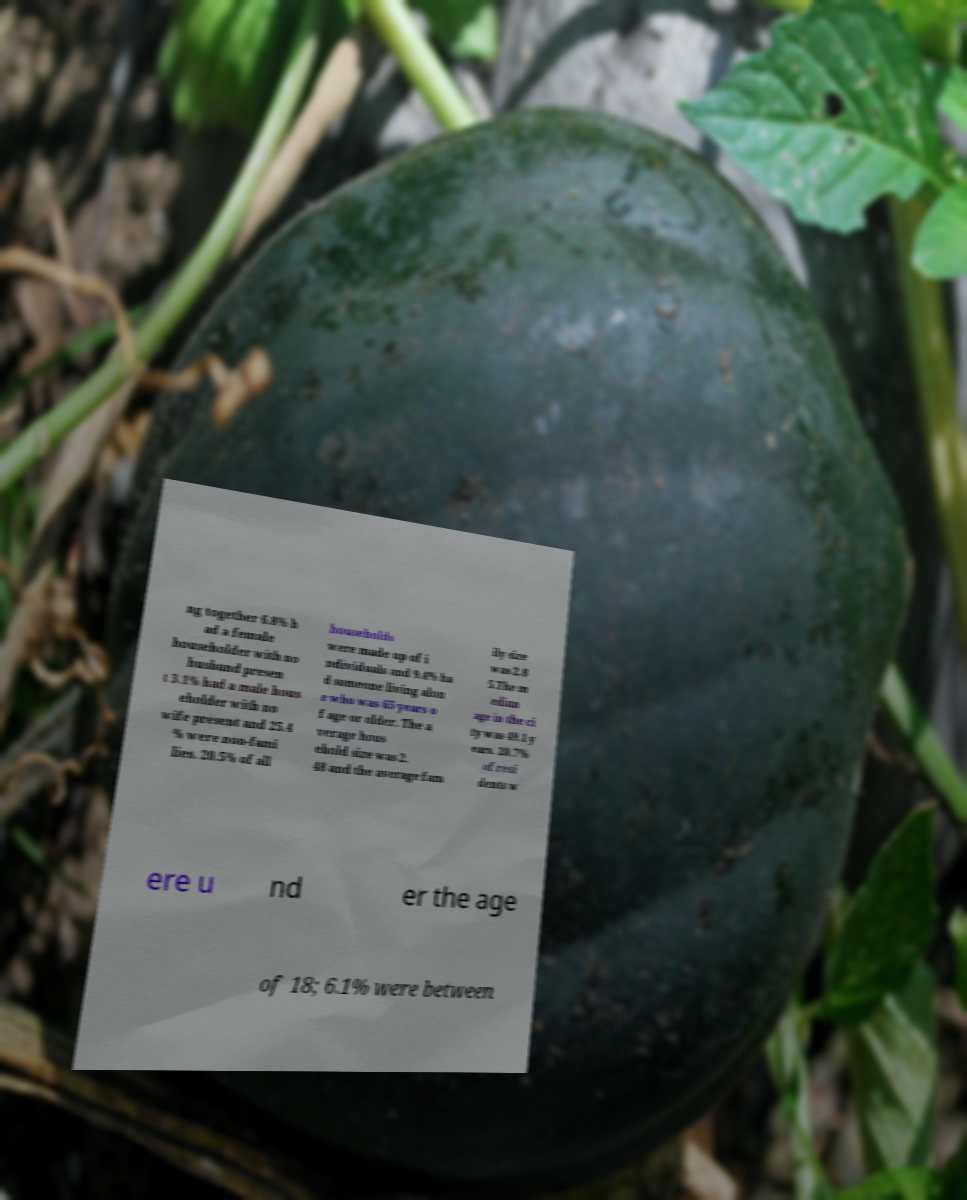For documentation purposes, I need the text within this image transcribed. Could you provide that? ng together 6.8% h ad a female householder with no husband presen t 3.1% had a male hous eholder with no wife present and 25.4 % were non-fami lies. 20.5% of all households were made up of i ndividuals and 9.4% ha d someone living alon e who was 65 years o f age or older. The a verage hous ehold size was 2. 48 and the average fam ily size was 2.8 5.The m edian age in the ci ty was 49.1 y ears. 20.7% of resi dents w ere u nd er the age of 18; 6.1% were between 